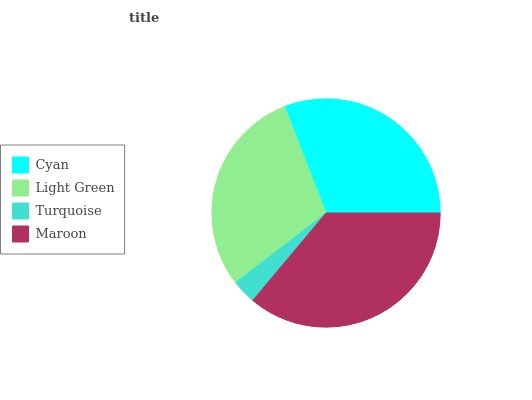Is Turquoise the minimum?
Answer yes or no. Yes. Is Maroon the maximum?
Answer yes or no. Yes. Is Light Green the minimum?
Answer yes or no. No. Is Light Green the maximum?
Answer yes or no. No. Is Cyan greater than Light Green?
Answer yes or no. Yes. Is Light Green less than Cyan?
Answer yes or no. Yes. Is Light Green greater than Cyan?
Answer yes or no. No. Is Cyan less than Light Green?
Answer yes or no. No. Is Cyan the high median?
Answer yes or no. Yes. Is Light Green the low median?
Answer yes or no. Yes. Is Maroon the high median?
Answer yes or no. No. Is Maroon the low median?
Answer yes or no. No. 